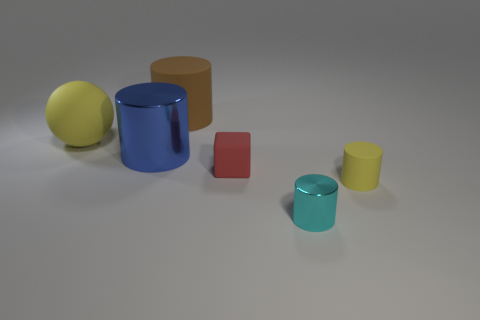Are there the same number of cyan metal things that are in front of the large shiny thing and cyan metal objects behind the big brown matte thing?
Offer a very short reply. No. The other large thing that is the same shape as the big metal object is what color?
Provide a short and direct response. Brown. Is there anything else that has the same color as the large ball?
Your response must be concise. Yes. What number of metallic objects are small cyan cylinders or tiny yellow objects?
Ensure brevity in your answer.  1. Is the color of the tiny cube the same as the small shiny cylinder?
Offer a very short reply. No. Is the number of big balls left of the yellow rubber ball greater than the number of big yellow balls?
Make the answer very short. No. How many other objects are the same material as the tiny yellow cylinder?
Give a very brief answer. 3. What number of tiny objects are either blue matte things or yellow matte balls?
Offer a terse response. 0. Is the material of the large blue cylinder the same as the cube?
Provide a short and direct response. No. How many tiny yellow matte objects are right of the large cylinder behind the blue object?
Your answer should be compact. 1. 